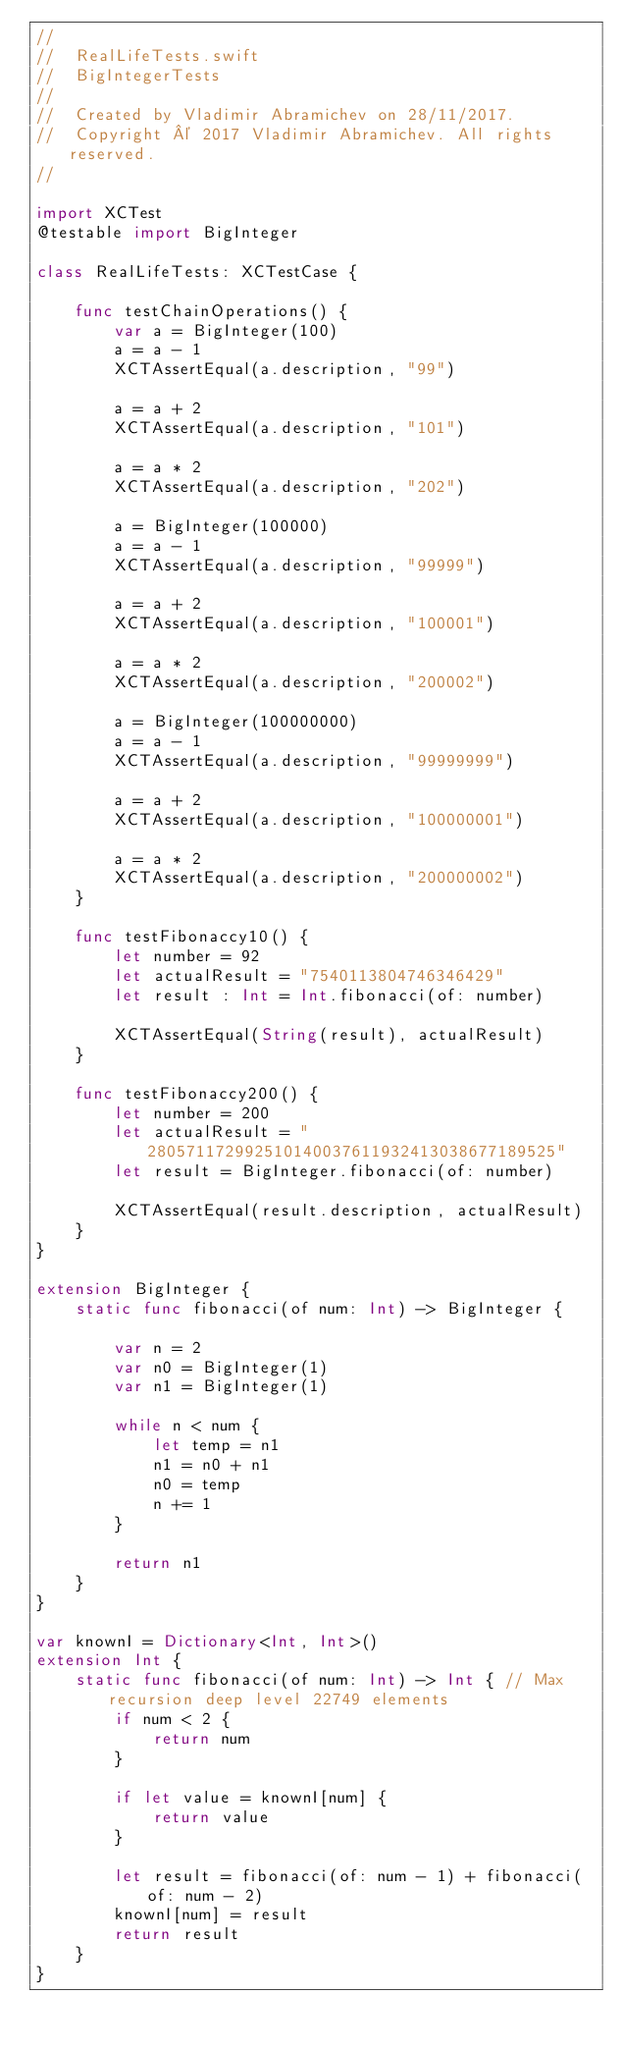Convert code to text. <code><loc_0><loc_0><loc_500><loc_500><_Swift_>//
//  RealLifeTests.swift
//  BigIntegerTests
//
//  Created by Vladimir Abramichev on 28/11/2017.
//  Copyright © 2017 Vladimir Abramichev. All rights reserved.
//

import XCTest
@testable import BigInteger

class RealLifeTests: XCTestCase {

    func testChainOperations() {
        var a = BigInteger(100)
        a = a - 1
        XCTAssertEqual(a.description, "99")

        a = a + 2
        XCTAssertEqual(a.description, "101")

        a = a * 2
        XCTAssertEqual(a.description, "202")

        a = BigInteger(100000)
        a = a - 1
        XCTAssertEqual(a.description, "99999")

        a = a + 2
        XCTAssertEqual(a.description, "100001")

        a = a * 2
        XCTAssertEqual(a.description, "200002")

        a = BigInteger(100000000)
        a = a - 1
        XCTAssertEqual(a.description, "99999999")

        a = a + 2
        XCTAssertEqual(a.description, "100000001")

        a = a * 2
        XCTAssertEqual(a.description, "200000002")
    }

    func testFibonaccy10() {
        let number = 92
        let actualResult = "7540113804746346429"
        let result : Int = Int.fibonacci(of: number)

        XCTAssertEqual(String(result), actualResult)
    }

    func testFibonaccy200() {
        let number = 200
        let actualResult = "280571172992510140037611932413038677189525"
        let result = BigInteger.fibonacci(of: number)

        XCTAssertEqual(result.description, actualResult)
    }
}

extension BigInteger {
    static func fibonacci(of num: Int) -> BigInteger {

        var n = 2
        var n0 = BigInteger(1)
        var n1 = BigInteger(1)

        while n < num {
            let temp = n1
            n1 = n0 + n1
            n0 = temp
            n += 1
        }

        return n1
    }
}

var knownI = Dictionary<Int, Int>()
extension Int {
    static func fibonacci(of num: Int) -> Int { // Max recursion deep level 22749 elements
        if num < 2 {
            return num
        }

        if let value = knownI[num] {
            return value
        }

        let result = fibonacci(of: num - 1) + fibonacci(of: num - 2)
        knownI[num] = result
        return result
    }
}
</code> 